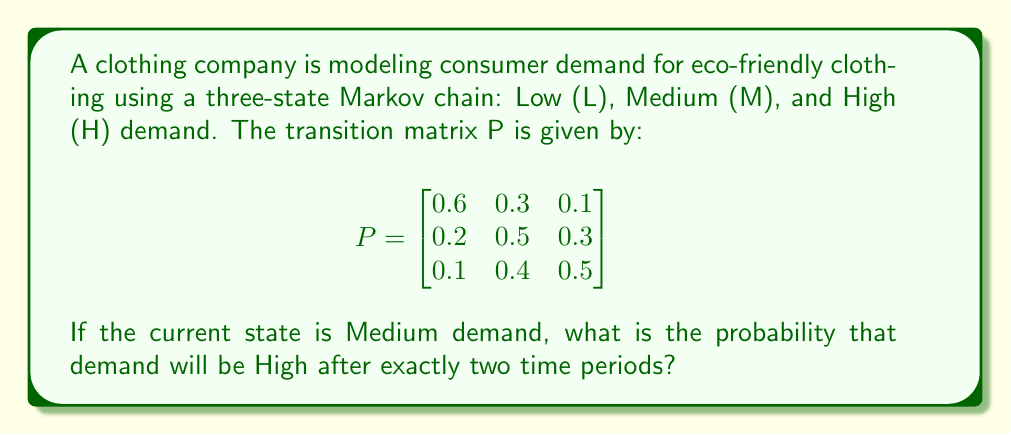Give your solution to this math problem. To solve this problem, we need to use the Chapman-Kolmogorov equations and matrix multiplication. Let's approach this step-by-step:

1) We start in the Medium (M) state, which corresponds to the second row of the transition matrix.

2) We need to calculate $P^2$, which gives us the two-step transition probabilities:

   $$P^2 = P \times P = \begin{bmatrix}
   0.6 & 0.3 & 0.1 \\
   0.2 & 0.5 & 0.3 \\
   0.1 & 0.4 & 0.5
   \end{bmatrix} \times \begin{bmatrix}
   0.6 & 0.3 & 0.1 \\
   0.2 & 0.5 & 0.3 \\
   0.1 & 0.4 & 0.5
   \end{bmatrix}$$

3) Performing the matrix multiplication:

   $$P^2 = \begin{bmatrix}
   0.42 & 0.39 & 0.19 \\
   0.25 & 0.46 & 0.29 \\
   0.20 & 0.46 & 0.34
   \end{bmatrix}$$

4) We're interested in the probability of going from Medium (M) to High (H) in two steps. This corresponds to the element in the second row, third column of $P^2$.

5) Therefore, the probability of going from Medium to High demand in two time periods is 0.29 or 29%.
Answer: 0.29 